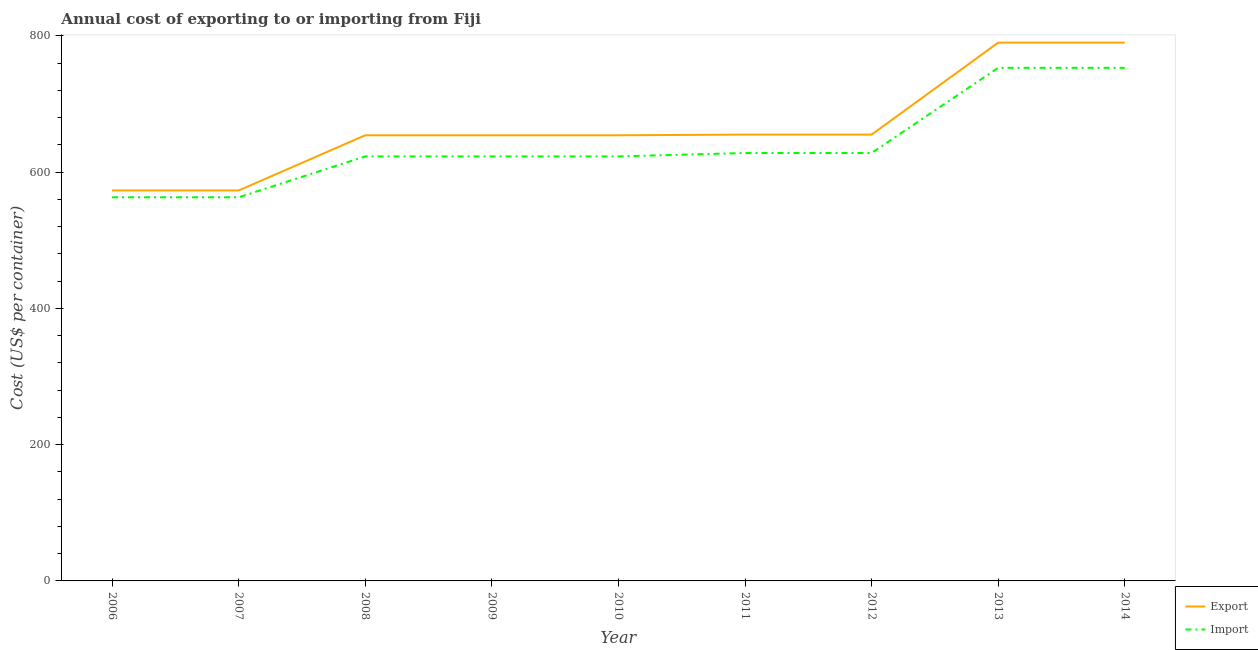How many different coloured lines are there?
Provide a succinct answer. 2. Does the line corresponding to import cost intersect with the line corresponding to export cost?
Keep it short and to the point. No. What is the import cost in 2013?
Offer a terse response. 753. Across all years, what is the maximum export cost?
Offer a terse response. 790. Across all years, what is the minimum export cost?
Ensure brevity in your answer.  573. What is the total import cost in the graph?
Provide a short and direct response. 5757. What is the difference between the import cost in 2008 and that in 2009?
Make the answer very short. 0. What is the difference between the import cost in 2014 and the export cost in 2010?
Keep it short and to the point. 99. What is the average import cost per year?
Keep it short and to the point. 639.67. In the year 2008, what is the difference between the import cost and export cost?
Provide a succinct answer. -31. What is the ratio of the import cost in 2006 to that in 2008?
Ensure brevity in your answer.  0.9. What is the difference between the highest and the lowest import cost?
Offer a terse response. 190. In how many years, is the export cost greater than the average export cost taken over all years?
Ensure brevity in your answer.  2. Is the sum of the export cost in 2007 and 2011 greater than the maximum import cost across all years?
Keep it short and to the point. Yes. How many years are there in the graph?
Provide a succinct answer. 9. Where does the legend appear in the graph?
Provide a succinct answer. Bottom right. What is the title of the graph?
Make the answer very short. Annual cost of exporting to or importing from Fiji. What is the label or title of the X-axis?
Offer a terse response. Year. What is the label or title of the Y-axis?
Ensure brevity in your answer.  Cost (US$ per container). What is the Cost (US$ per container) in Export in 2006?
Provide a succinct answer. 573. What is the Cost (US$ per container) of Import in 2006?
Your answer should be very brief. 563. What is the Cost (US$ per container) of Export in 2007?
Your response must be concise. 573. What is the Cost (US$ per container) of Import in 2007?
Provide a succinct answer. 563. What is the Cost (US$ per container) in Export in 2008?
Give a very brief answer. 654. What is the Cost (US$ per container) in Import in 2008?
Keep it short and to the point. 623. What is the Cost (US$ per container) in Export in 2009?
Make the answer very short. 654. What is the Cost (US$ per container) in Import in 2009?
Offer a terse response. 623. What is the Cost (US$ per container) in Export in 2010?
Provide a short and direct response. 654. What is the Cost (US$ per container) of Import in 2010?
Provide a short and direct response. 623. What is the Cost (US$ per container) in Export in 2011?
Your answer should be very brief. 655. What is the Cost (US$ per container) in Import in 2011?
Ensure brevity in your answer.  628. What is the Cost (US$ per container) in Export in 2012?
Offer a very short reply. 655. What is the Cost (US$ per container) in Import in 2012?
Keep it short and to the point. 628. What is the Cost (US$ per container) in Export in 2013?
Provide a short and direct response. 790. What is the Cost (US$ per container) of Import in 2013?
Make the answer very short. 753. What is the Cost (US$ per container) in Export in 2014?
Ensure brevity in your answer.  790. What is the Cost (US$ per container) of Import in 2014?
Offer a terse response. 753. Across all years, what is the maximum Cost (US$ per container) in Export?
Give a very brief answer. 790. Across all years, what is the maximum Cost (US$ per container) of Import?
Offer a very short reply. 753. Across all years, what is the minimum Cost (US$ per container) of Export?
Offer a terse response. 573. Across all years, what is the minimum Cost (US$ per container) in Import?
Keep it short and to the point. 563. What is the total Cost (US$ per container) in Export in the graph?
Give a very brief answer. 5998. What is the total Cost (US$ per container) in Import in the graph?
Your answer should be compact. 5757. What is the difference between the Cost (US$ per container) in Import in 2006 and that in 2007?
Your answer should be compact. 0. What is the difference between the Cost (US$ per container) of Export in 2006 and that in 2008?
Your answer should be very brief. -81. What is the difference between the Cost (US$ per container) in Import in 2006 and that in 2008?
Your answer should be very brief. -60. What is the difference between the Cost (US$ per container) in Export in 2006 and that in 2009?
Give a very brief answer. -81. What is the difference between the Cost (US$ per container) of Import in 2006 and that in 2009?
Make the answer very short. -60. What is the difference between the Cost (US$ per container) in Export in 2006 and that in 2010?
Keep it short and to the point. -81. What is the difference between the Cost (US$ per container) of Import in 2006 and that in 2010?
Keep it short and to the point. -60. What is the difference between the Cost (US$ per container) in Export in 2006 and that in 2011?
Offer a terse response. -82. What is the difference between the Cost (US$ per container) in Import in 2006 and that in 2011?
Your answer should be compact. -65. What is the difference between the Cost (US$ per container) of Export in 2006 and that in 2012?
Offer a very short reply. -82. What is the difference between the Cost (US$ per container) in Import in 2006 and that in 2012?
Offer a very short reply. -65. What is the difference between the Cost (US$ per container) in Export in 2006 and that in 2013?
Ensure brevity in your answer.  -217. What is the difference between the Cost (US$ per container) in Import in 2006 and that in 2013?
Offer a very short reply. -190. What is the difference between the Cost (US$ per container) of Export in 2006 and that in 2014?
Provide a short and direct response. -217. What is the difference between the Cost (US$ per container) in Import in 2006 and that in 2014?
Offer a very short reply. -190. What is the difference between the Cost (US$ per container) of Export in 2007 and that in 2008?
Your answer should be compact. -81. What is the difference between the Cost (US$ per container) in Import in 2007 and that in 2008?
Offer a terse response. -60. What is the difference between the Cost (US$ per container) of Export in 2007 and that in 2009?
Provide a short and direct response. -81. What is the difference between the Cost (US$ per container) of Import in 2007 and that in 2009?
Provide a short and direct response. -60. What is the difference between the Cost (US$ per container) in Export in 2007 and that in 2010?
Offer a very short reply. -81. What is the difference between the Cost (US$ per container) in Import in 2007 and that in 2010?
Offer a very short reply. -60. What is the difference between the Cost (US$ per container) of Export in 2007 and that in 2011?
Keep it short and to the point. -82. What is the difference between the Cost (US$ per container) in Import in 2007 and that in 2011?
Make the answer very short. -65. What is the difference between the Cost (US$ per container) in Export in 2007 and that in 2012?
Your answer should be compact. -82. What is the difference between the Cost (US$ per container) in Import in 2007 and that in 2012?
Your answer should be compact. -65. What is the difference between the Cost (US$ per container) of Export in 2007 and that in 2013?
Give a very brief answer. -217. What is the difference between the Cost (US$ per container) in Import in 2007 and that in 2013?
Offer a very short reply. -190. What is the difference between the Cost (US$ per container) of Export in 2007 and that in 2014?
Your answer should be compact. -217. What is the difference between the Cost (US$ per container) in Import in 2007 and that in 2014?
Keep it short and to the point. -190. What is the difference between the Cost (US$ per container) of Export in 2008 and that in 2009?
Offer a very short reply. 0. What is the difference between the Cost (US$ per container) in Import in 2008 and that in 2009?
Ensure brevity in your answer.  0. What is the difference between the Cost (US$ per container) of Import in 2008 and that in 2010?
Your answer should be compact. 0. What is the difference between the Cost (US$ per container) in Import in 2008 and that in 2011?
Your response must be concise. -5. What is the difference between the Cost (US$ per container) in Export in 2008 and that in 2013?
Provide a succinct answer. -136. What is the difference between the Cost (US$ per container) in Import in 2008 and that in 2013?
Offer a terse response. -130. What is the difference between the Cost (US$ per container) of Export in 2008 and that in 2014?
Make the answer very short. -136. What is the difference between the Cost (US$ per container) in Import in 2008 and that in 2014?
Ensure brevity in your answer.  -130. What is the difference between the Cost (US$ per container) of Export in 2009 and that in 2010?
Offer a terse response. 0. What is the difference between the Cost (US$ per container) in Import in 2009 and that in 2010?
Your answer should be very brief. 0. What is the difference between the Cost (US$ per container) of Export in 2009 and that in 2011?
Offer a terse response. -1. What is the difference between the Cost (US$ per container) of Import in 2009 and that in 2011?
Provide a succinct answer. -5. What is the difference between the Cost (US$ per container) in Import in 2009 and that in 2012?
Your answer should be very brief. -5. What is the difference between the Cost (US$ per container) in Export in 2009 and that in 2013?
Your answer should be very brief. -136. What is the difference between the Cost (US$ per container) of Import in 2009 and that in 2013?
Your answer should be compact. -130. What is the difference between the Cost (US$ per container) of Export in 2009 and that in 2014?
Make the answer very short. -136. What is the difference between the Cost (US$ per container) in Import in 2009 and that in 2014?
Give a very brief answer. -130. What is the difference between the Cost (US$ per container) of Export in 2010 and that in 2011?
Offer a terse response. -1. What is the difference between the Cost (US$ per container) of Export in 2010 and that in 2012?
Your response must be concise. -1. What is the difference between the Cost (US$ per container) in Export in 2010 and that in 2013?
Offer a terse response. -136. What is the difference between the Cost (US$ per container) in Import in 2010 and that in 2013?
Offer a very short reply. -130. What is the difference between the Cost (US$ per container) of Export in 2010 and that in 2014?
Give a very brief answer. -136. What is the difference between the Cost (US$ per container) in Import in 2010 and that in 2014?
Offer a terse response. -130. What is the difference between the Cost (US$ per container) in Export in 2011 and that in 2013?
Give a very brief answer. -135. What is the difference between the Cost (US$ per container) of Import in 2011 and that in 2013?
Your response must be concise. -125. What is the difference between the Cost (US$ per container) in Export in 2011 and that in 2014?
Keep it short and to the point. -135. What is the difference between the Cost (US$ per container) in Import in 2011 and that in 2014?
Your answer should be very brief. -125. What is the difference between the Cost (US$ per container) of Export in 2012 and that in 2013?
Keep it short and to the point. -135. What is the difference between the Cost (US$ per container) in Import in 2012 and that in 2013?
Offer a very short reply. -125. What is the difference between the Cost (US$ per container) in Export in 2012 and that in 2014?
Provide a succinct answer. -135. What is the difference between the Cost (US$ per container) of Import in 2012 and that in 2014?
Make the answer very short. -125. What is the difference between the Cost (US$ per container) in Export in 2013 and that in 2014?
Offer a very short reply. 0. What is the difference between the Cost (US$ per container) of Import in 2013 and that in 2014?
Make the answer very short. 0. What is the difference between the Cost (US$ per container) of Export in 2006 and the Cost (US$ per container) of Import in 2007?
Provide a succinct answer. 10. What is the difference between the Cost (US$ per container) in Export in 2006 and the Cost (US$ per container) in Import in 2010?
Give a very brief answer. -50. What is the difference between the Cost (US$ per container) in Export in 2006 and the Cost (US$ per container) in Import in 2011?
Give a very brief answer. -55. What is the difference between the Cost (US$ per container) in Export in 2006 and the Cost (US$ per container) in Import in 2012?
Provide a succinct answer. -55. What is the difference between the Cost (US$ per container) of Export in 2006 and the Cost (US$ per container) of Import in 2013?
Give a very brief answer. -180. What is the difference between the Cost (US$ per container) of Export in 2006 and the Cost (US$ per container) of Import in 2014?
Give a very brief answer. -180. What is the difference between the Cost (US$ per container) of Export in 2007 and the Cost (US$ per container) of Import in 2008?
Keep it short and to the point. -50. What is the difference between the Cost (US$ per container) in Export in 2007 and the Cost (US$ per container) in Import in 2009?
Provide a short and direct response. -50. What is the difference between the Cost (US$ per container) in Export in 2007 and the Cost (US$ per container) in Import in 2011?
Provide a succinct answer. -55. What is the difference between the Cost (US$ per container) of Export in 2007 and the Cost (US$ per container) of Import in 2012?
Offer a terse response. -55. What is the difference between the Cost (US$ per container) in Export in 2007 and the Cost (US$ per container) in Import in 2013?
Your answer should be very brief. -180. What is the difference between the Cost (US$ per container) of Export in 2007 and the Cost (US$ per container) of Import in 2014?
Keep it short and to the point. -180. What is the difference between the Cost (US$ per container) in Export in 2008 and the Cost (US$ per container) in Import in 2011?
Your answer should be very brief. 26. What is the difference between the Cost (US$ per container) in Export in 2008 and the Cost (US$ per container) in Import in 2012?
Make the answer very short. 26. What is the difference between the Cost (US$ per container) of Export in 2008 and the Cost (US$ per container) of Import in 2013?
Offer a terse response. -99. What is the difference between the Cost (US$ per container) of Export in 2008 and the Cost (US$ per container) of Import in 2014?
Make the answer very short. -99. What is the difference between the Cost (US$ per container) of Export in 2009 and the Cost (US$ per container) of Import in 2010?
Provide a short and direct response. 31. What is the difference between the Cost (US$ per container) of Export in 2009 and the Cost (US$ per container) of Import in 2013?
Give a very brief answer. -99. What is the difference between the Cost (US$ per container) in Export in 2009 and the Cost (US$ per container) in Import in 2014?
Keep it short and to the point. -99. What is the difference between the Cost (US$ per container) in Export in 2010 and the Cost (US$ per container) in Import in 2012?
Make the answer very short. 26. What is the difference between the Cost (US$ per container) in Export in 2010 and the Cost (US$ per container) in Import in 2013?
Your response must be concise. -99. What is the difference between the Cost (US$ per container) in Export in 2010 and the Cost (US$ per container) in Import in 2014?
Offer a terse response. -99. What is the difference between the Cost (US$ per container) in Export in 2011 and the Cost (US$ per container) in Import in 2013?
Offer a very short reply. -98. What is the difference between the Cost (US$ per container) in Export in 2011 and the Cost (US$ per container) in Import in 2014?
Ensure brevity in your answer.  -98. What is the difference between the Cost (US$ per container) of Export in 2012 and the Cost (US$ per container) of Import in 2013?
Your answer should be compact. -98. What is the difference between the Cost (US$ per container) of Export in 2012 and the Cost (US$ per container) of Import in 2014?
Offer a terse response. -98. What is the difference between the Cost (US$ per container) of Export in 2013 and the Cost (US$ per container) of Import in 2014?
Provide a short and direct response. 37. What is the average Cost (US$ per container) in Export per year?
Provide a short and direct response. 666.44. What is the average Cost (US$ per container) of Import per year?
Your response must be concise. 639.67. In the year 2009, what is the difference between the Cost (US$ per container) of Export and Cost (US$ per container) of Import?
Offer a terse response. 31. In the year 2011, what is the difference between the Cost (US$ per container) of Export and Cost (US$ per container) of Import?
Keep it short and to the point. 27. In the year 2012, what is the difference between the Cost (US$ per container) in Export and Cost (US$ per container) in Import?
Offer a terse response. 27. In the year 2013, what is the difference between the Cost (US$ per container) in Export and Cost (US$ per container) in Import?
Your answer should be compact. 37. What is the ratio of the Cost (US$ per container) of Import in 2006 to that in 2007?
Make the answer very short. 1. What is the ratio of the Cost (US$ per container) of Export in 2006 to that in 2008?
Provide a short and direct response. 0.88. What is the ratio of the Cost (US$ per container) of Import in 2006 to that in 2008?
Keep it short and to the point. 0.9. What is the ratio of the Cost (US$ per container) of Export in 2006 to that in 2009?
Make the answer very short. 0.88. What is the ratio of the Cost (US$ per container) of Import in 2006 to that in 2009?
Provide a succinct answer. 0.9. What is the ratio of the Cost (US$ per container) in Export in 2006 to that in 2010?
Your answer should be compact. 0.88. What is the ratio of the Cost (US$ per container) in Import in 2006 to that in 2010?
Ensure brevity in your answer.  0.9. What is the ratio of the Cost (US$ per container) in Export in 2006 to that in 2011?
Ensure brevity in your answer.  0.87. What is the ratio of the Cost (US$ per container) in Import in 2006 to that in 2011?
Ensure brevity in your answer.  0.9. What is the ratio of the Cost (US$ per container) of Export in 2006 to that in 2012?
Give a very brief answer. 0.87. What is the ratio of the Cost (US$ per container) of Import in 2006 to that in 2012?
Make the answer very short. 0.9. What is the ratio of the Cost (US$ per container) of Export in 2006 to that in 2013?
Your answer should be very brief. 0.73. What is the ratio of the Cost (US$ per container) of Import in 2006 to that in 2013?
Your answer should be very brief. 0.75. What is the ratio of the Cost (US$ per container) of Export in 2006 to that in 2014?
Provide a short and direct response. 0.73. What is the ratio of the Cost (US$ per container) of Import in 2006 to that in 2014?
Give a very brief answer. 0.75. What is the ratio of the Cost (US$ per container) in Export in 2007 to that in 2008?
Give a very brief answer. 0.88. What is the ratio of the Cost (US$ per container) of Import in 2007 to that in 2008?
Keep it short and to the point. 0.9. What is the ratio of the Cost (US$ per container) in Export in 2007 to that in 2009?
Offer a very short reply. 0.88. What is the ratio of the Cost (US$ per container) of Import in 2007 to that in 2009?
Keep it short and to the point. 0.9. What is the ratio of the Cost (US$ per container) in Export in 2007 to that in 2010?
Provide a short and direct response. 0.88. What is the ratio of the Cost (US$ per container) of Import in 2007 to that in 2010?
Keep it short and to the point. 0.9. What is the ratio of the Cost (US$ per container) of Export in 2007 to that in 2011?
Offer a very short reply. 0.87. What is the ratio of the Cost (US$ per container) in Import in 2007 to that in 2011?
Your answer should be very brief. 0.9. What is the ratio of the Cost (US$ per container) in Export in 2007 to that in 2012?
Your response must be concise. 0.87. What is the ratio of the Cost (US$ per container) of Import in 2007 to that in 2012?
Ensure brevity in your answer.  0.9. What is the ratio of the Cost (US$ per container) of Export in 2007 to that in 2013?
Offer a very short reply. 0.73. What is the ratio of the Cost (US$ per container) of Import in 2007 to that in 2013?
Provide a succinct answer. 0.75. What is the ratio of the Cost (US$ per container) of Export in 2007 to that in 2014?
Ensure brevity in your answer.  0.73. What is the ratio of the Cost (US$ per container) in Import in 2007 to that in 2014?
Provide a succinct answer. 0.75. What is the ratio of the Cost (US$ per container) in Export in 2008 to that in 2009?
Offer a terse response. 1. What is the ratio of the Cost (US$ per container) of Export in 2008 to that in 2010?
Give a very brief answer. 1. What is the ratio of the Cost (US$ per container) in Import in 2008 to that in 2012?
Offer a very short reply. 0.99. What is the ratio of the Cost (US$ per container) in Export in 2008 to that in 2013?
Keep it short and to the point. 0.83. What is the ratio of the Cost (US$ per container) in Import in 2008 to that in 2013?
Offer a very short reply. 0.83. What is the ratio of the Cost (US$ per container) of Export in 2008 to that in 2014?
Provide a succinct answer. 0.83. What is the ratio of the Cost (US$ per container) of Import in 2008 to that in 2014?
Offer a very short reply. 0.83. What is the ratio of the Cost (US$ per container) in Export in 2009 to that in 2010?
Provide a succinct answer. 1. What is the ratio of the Cost (US$ per container) in Import in 2009 to that in 2010?
Provide a succinct answer. 1. What is the ratio of the Cost (US$ per container) of Export in 2009 to that in 2011?
Your answer should be very brief. 1. What is the ratio of the Cost (US$ per container) in Import in 2009 to that in 2011?
Your answer should be very brief. 0.99. What is the ratio of the Cost (US$ per container) of Export in 2009 to that in 2012?
Give a very brief answer. 1. What is the ratio of the Cost (US$ per container) of Import in 2009 to that in 2012?
Your response must be concise. 0.99. What is the ratio of the Cost (US$ per container) of Export in 2009 to that in 2013?
Ensure brevity in your answer.  0.83. What is the ratio of the Cost (US$ per container) in Import in 2009 to that in 2013?
Offer a very short reply. 0.83. What is the ratio of the Cost (US$ per container) of Export in 2009 to that in 2014?
Provide a succinct answer. 0.83. What is the ratio of the Cost (US$ per container) in Import in 2009 to that in 2014?
Give a very brief answer. 0.83. What is the ratio of the Cost (US$ per container) in Export in 2010 to that in 2011?
Your response must be concise. 1. What is the ratio of the Cost (US$ per container) in Import in 2010 to that in 2011?
Your response must be concise. 0.99. What is the ratio of the Cost (US$ per container) of Export in 2010 to that in 2012?
Ensure brevity in your answer.  1. What is the ratio of the Cost (US$ per container) of Export in 2010 to that in 2013?
Ensure brevity in your answer.  0.83. What is the ratio of the Cost (US$ per container) in Import in 2010 to that in 2013?
Offer a terse response. 0.83. What is the ratio of the Cost (US$ per container) of Export in 2010 to that in 2014?
Make the answer very short. 0.83. What is the ratio of the Cost (US$ per container) in Import in 2010 to that in 2014?
Give a very brief answer. 0.83. What is the ratio of the Cost (US$ per container) of Import in 2011 to that in 2012?
Your answer should be compact. 1. What is the ratio of the Cost (US$ per container) of Export in 2011 to that in 2013?
Your answer should be compact. 0.83. What is the ratio of the Cost (US$ per container) in Import in 2011 to that in 2013?
Offer a terse response. 0.83. What is the ratio of the Cost (US$ per container) of Export in 2011 to that in 2014?
Your response must be concise. 0.83. What is the ratio of the Cost (US$ per container) in Import in 2011 to that in 2014?
Make the answer very short. 0.83. What is the ratio of the Cost (US$ per container) in Export in 2012 to that in 2013?
Ensure brevity in your answer.  0.83. What is the ratio of the Cost (US$ per container) in Import in 2012 to that in 2013?
Ensure brevity in your answer.  0.83. What is the ratio of the Cost (US$ per container) in Export in 2012 to that in 2014?
Your answer should be very brief. 0.83. What is the ratio of the Cost (US$ per container) in Import in 2012 to that in 2014?
Provide a succinct answer. 0.83. What is the difference between the highest and the lowest Cost (US$ per container) in Export?
Your answer should be very brief. 217. What is the difference between the highest and the lowest Cost (US$ per container) of Import?
Your answer should be very brief. 190. 